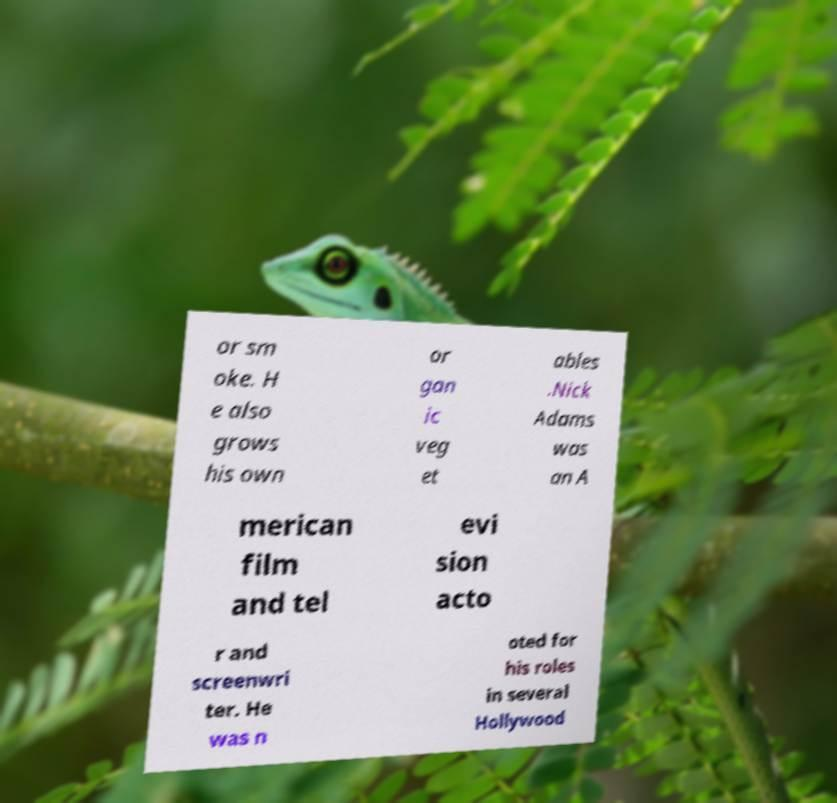Could you assist in decoding the text presented in this image and type it out clearly? or sm oke. H e also grows his own or gan ic veg et ables .Nick Adams was an A merican film and tel evi sion acto r and screenwri ter. He was n oted for his roles in several Hollywood 